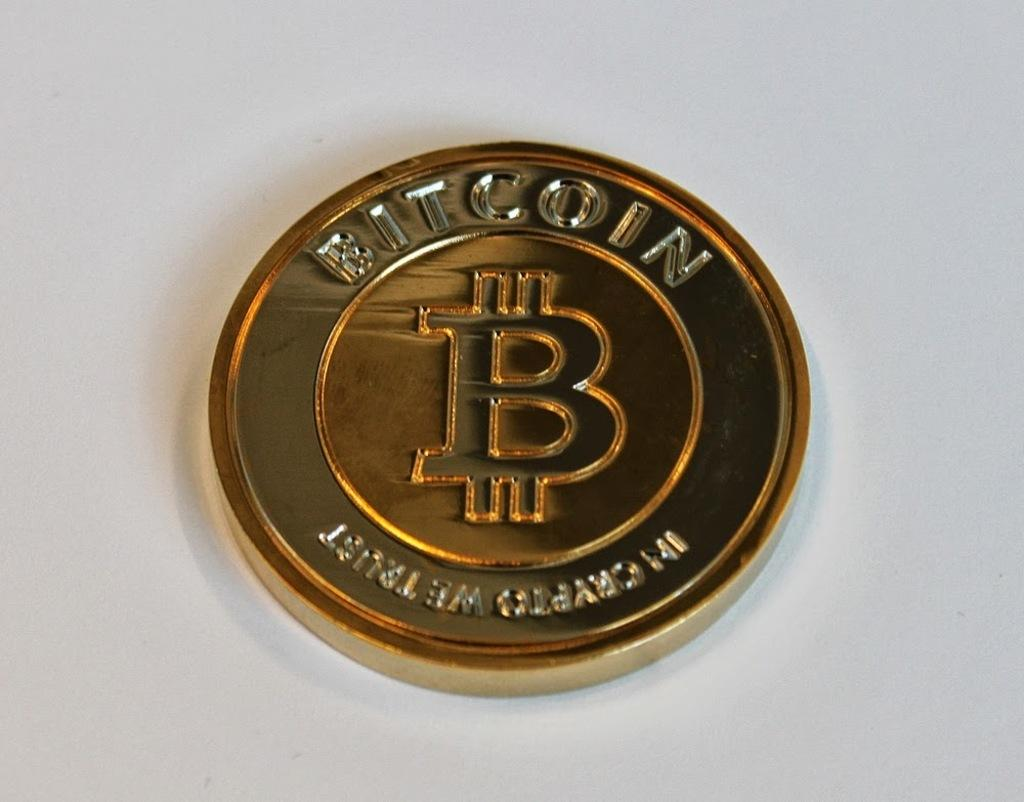<image>
Share a concise interpretation of the image provided. A coin that says BITCOIN placed on a white surface. 